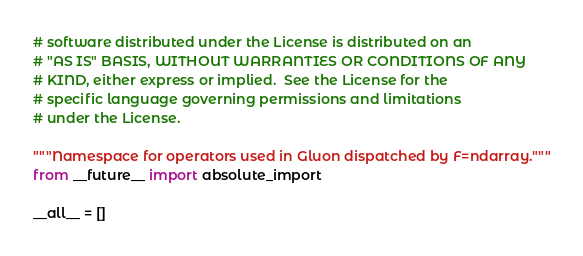Convert code to text. <code><loc_0><loc_0><loc_500><loc_500><_Python_># software distributed under the License is distributed on an
# "AS IS" BASIS, WITHOUT WARRANTIES OR CONDITIONS OF ANY
# KIND, either express or implied.  See the License for the
# specific language governing permissions and limitations
# under the License.

"""Namespace for operators used in Gluon dispatched by F=ndarray."""
from __future__ import absolute_import

__all__ = []
</code> 